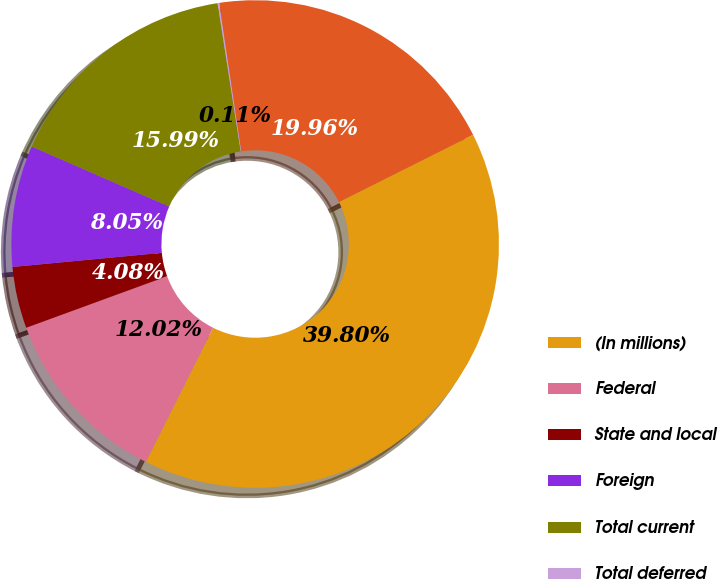Convert chart. <chart><loc_0><loc_0><loc_500><loc_500><pie_chart><fcel>(In millions)<fcel>Federal<fcel>State and local<fcel>Foreign<fcel>Total current<fcel>Total deferred<fcel>Taxes on earnings<nl><fcel>39.8%<fcel>12.02%<fcel>4.08%<fcel>8.05%<fcel>15.99%<fcel>0.11%<fcel>19.96%<nl></chart> 